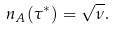Convert formula to latex. <formula><loc_0><loc_0><loc_500><loc_500>n _ { A } ( \tau ^ { * } ) = \sqrt { \nu } .</formula> 